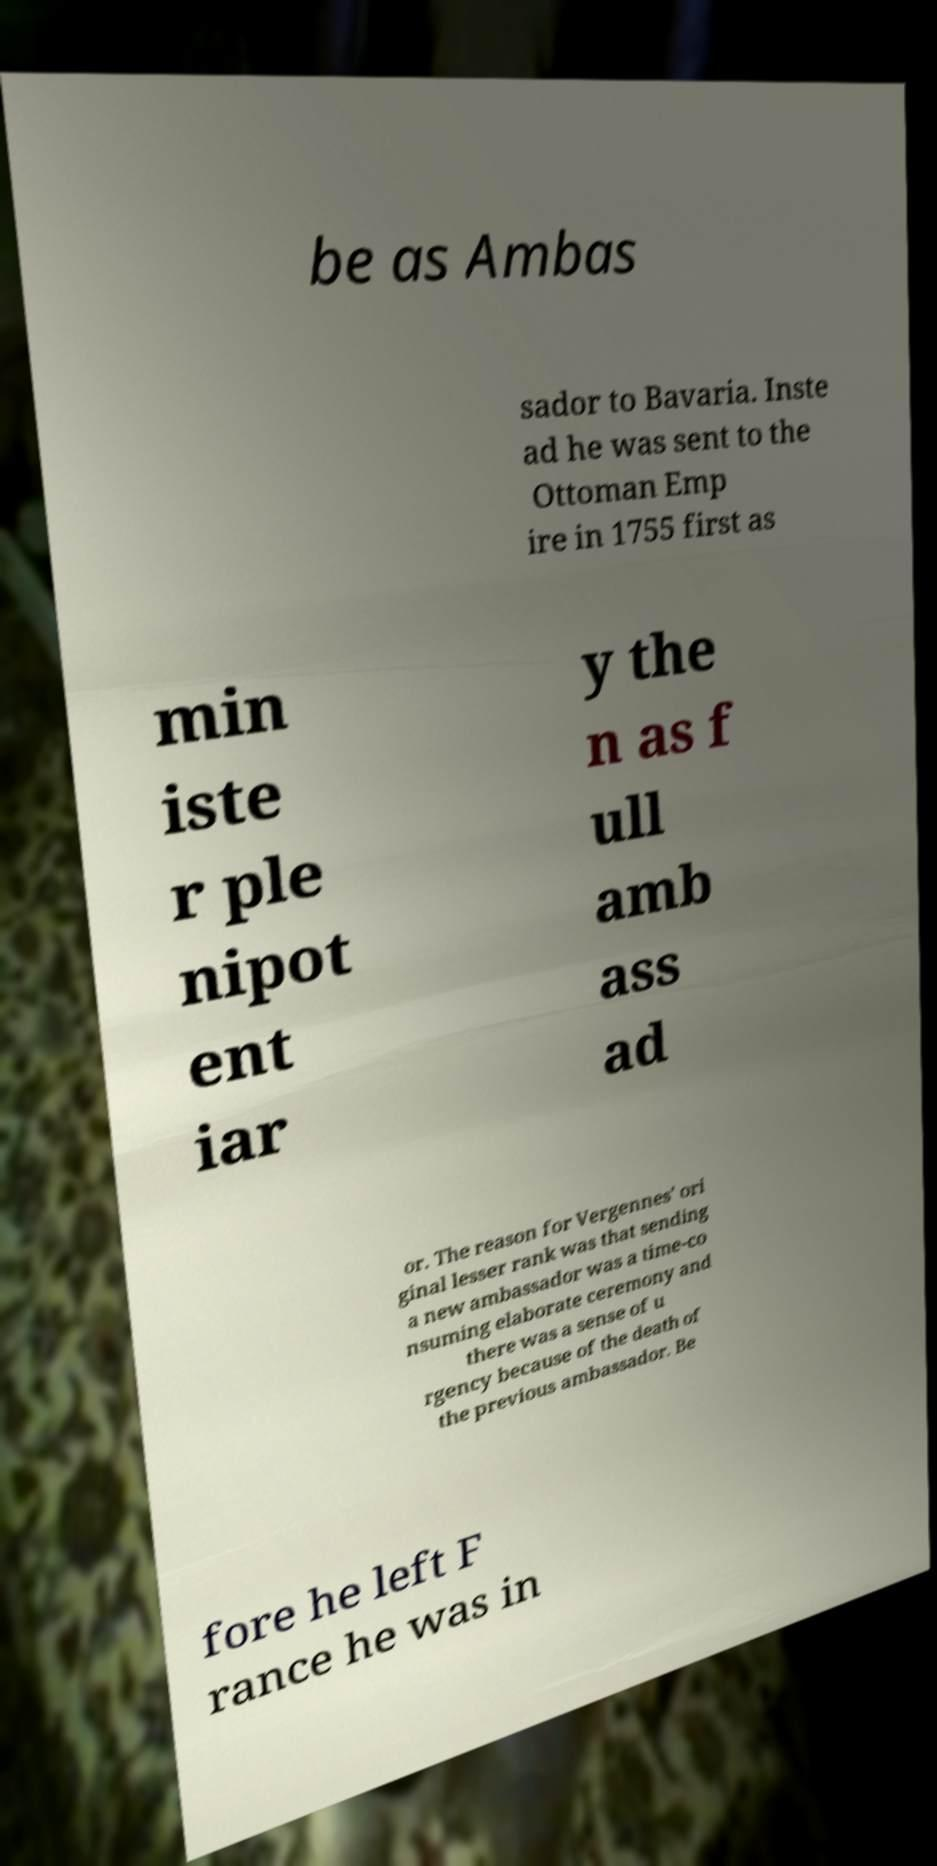For documentation purposes, I need the text within this image transcribed. Could you provide that? be as Ambas sador to Bavaria. Inste ad he was sent to the Ottoman Emp ire in 1755 first as min iste r ple nipot ent iar y the n as f ull amb ass ad or. The reason for Vergennes' ori ginal lesser rank was that sending a new ambassador was a time-co nsuming elaborate ceremony and there was a sense of u rgency because of the death of the previous ambassador. Be fore he left F rance he was in 